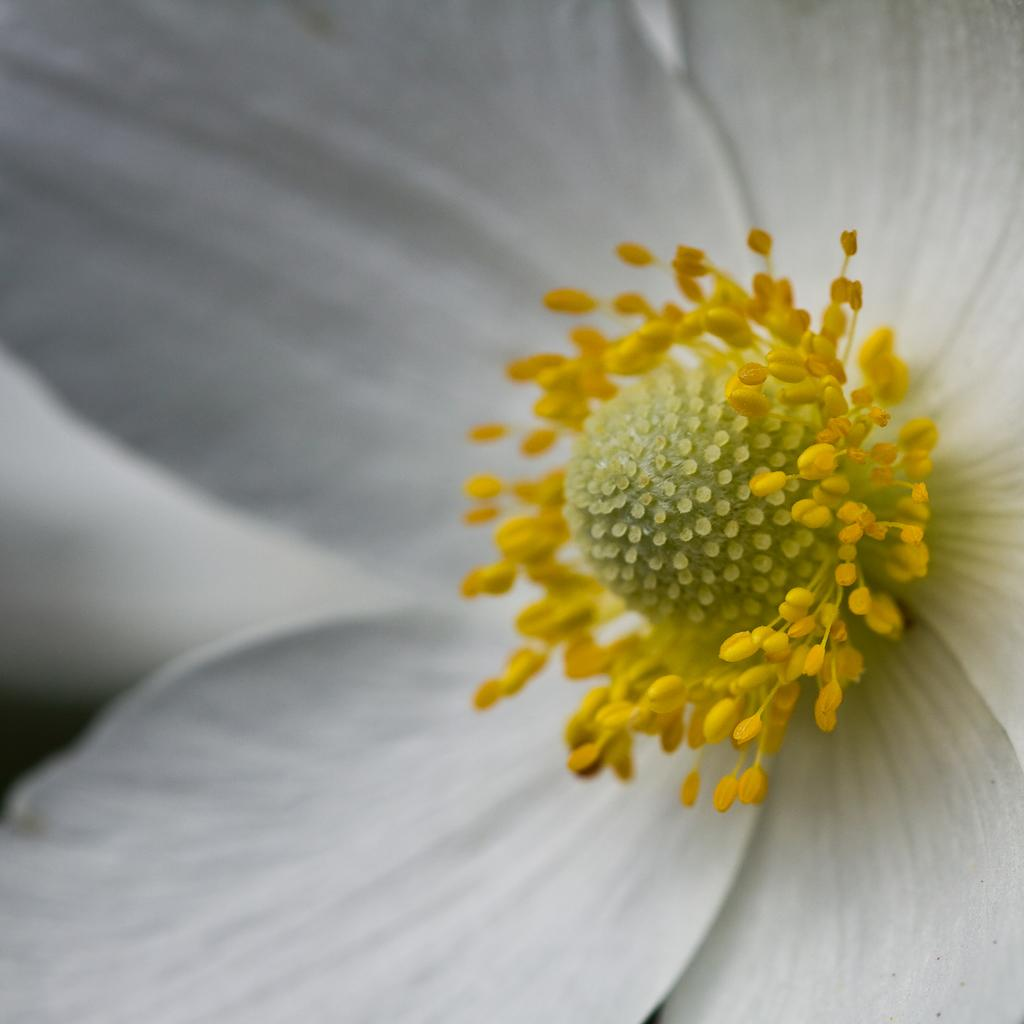What type of flower is present in the image? There is a white color flower in the image. What can be seen on the flower in the image? There are yellow color pollen grains in the image. What type of game is being played in the image? There is no game present in the image; it features a white flower with yellow pollen grains. What is the zebra's role in the image? There is no zebra present in the image. 